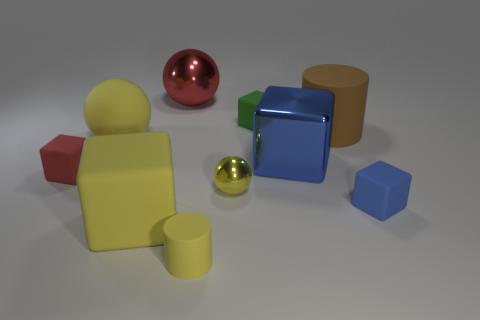Which object in the image seems to reflect the most light? The sphere on the left appears to be the most reflective object, given its shiny surface that mirrors its environment with a high degree of clarity. 